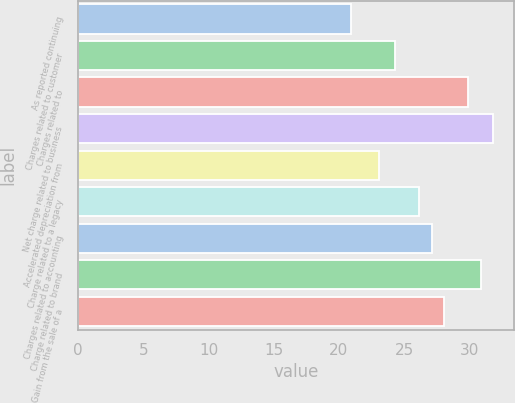Convert chart to OTSL. <chart><loc_0><loc_0><loc_500><loc_500><bar_chart><fcel>As reported continuing<fcel>Charges related to customer<fcel>Charges related to<fcel>Net charge related to business<fcel>Accelerated depreciation from<fcel>Charge related to a legacy<fcel>Charges related to accounting<fcel>Charge related to brand<fcel>Gain from the sale of a<nl><fcel>20.9<fcel>24.3<fcel>29.94<fcel>31.82<fcel>23.04<fcel>26.18<fcel>27.12<fcel>30.88<fcel>28.06<nl></chart> 